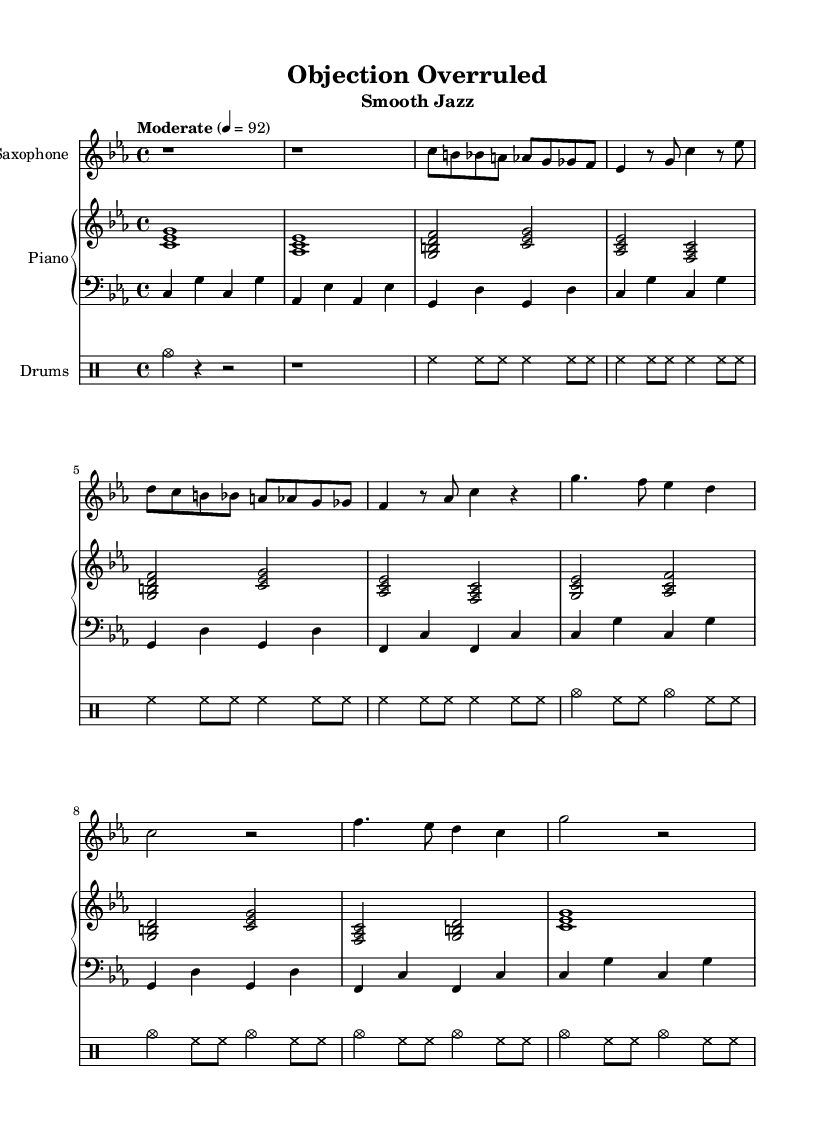What is the key signature of this music? The key signature indicates that the piece is in C minor, which typically has three flats (B flat, E flat, and A flat), confirmed by the presence of these notes in the stemmed music.
Answer: C minor What is the time signature of this music? The time signature displayed at the beginning of the staff shows 4/4, indicating there are four beats in a measure and a quarter note gets one beat.
Answer: 4/4 What is the tempo marking of the piece? The tempo marking indicates a moderate speed set at 92 beats per minute, which provides a guideline for how fast the music should be played.
Answer: Moderate, 92 How many measures are there in the chorus? To determine the number of measures, one can visually count the measures in the score section labeled as the chorus, which consists of four distinct measures.
Answer: Four Which instrument has the melody in the verse? The melody in the verse is primarily presented by the saxophone, as it plays the leading phrase throughout this section of the sheet music.
Answer: Saxophone What type of jazz does this piece represent? This piece represents smooth jazz, a subgenre characterized by its mellow sound and relaxed instrumentation, fitting the courtroom drama vibe.
Answer: Smooth jazz In what year was the music sheet created? The version of LilyPond used to create the score is noted as "2.22.1," indicating the specific software version at the time of creation, but there’s no explicit creation date given.
Answer: 2022 (Version reference) 